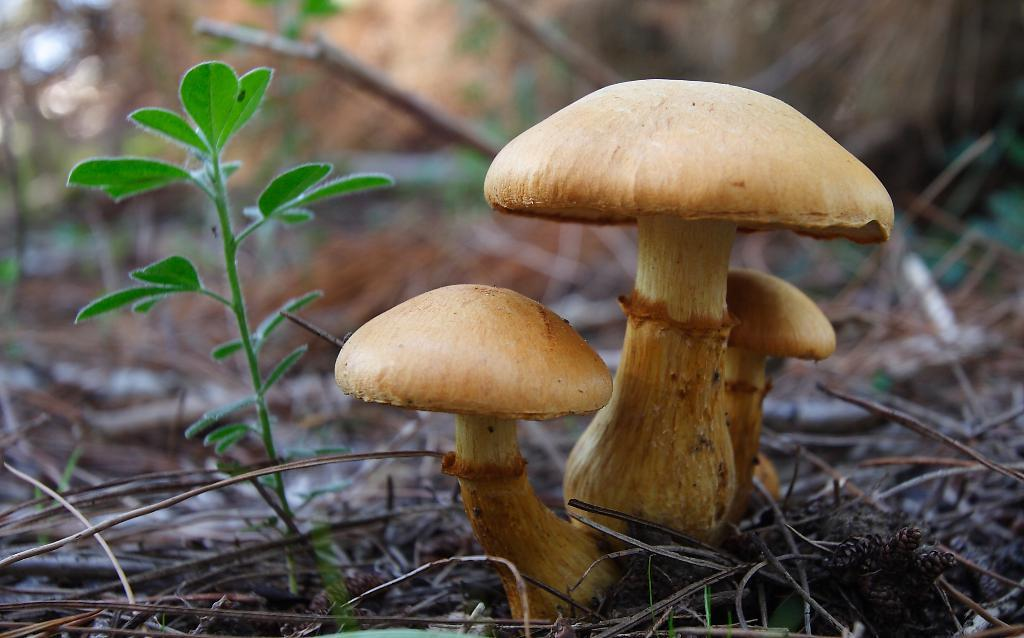What type of fungi can be seen in the image? The image contains mushrooms. Where is the small plant located in the image? The small plant is on the left side of the image. What objects are present at the bottom of the image? There are small sticks at the bottom of the image. How much value does the baby bring to the image? There is no baby present in the image, so it cannot bring any value to the image. 